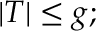<formula> <loc_0><loc_0><loc_500><loc_500>| T | \leq g ;</formula> 